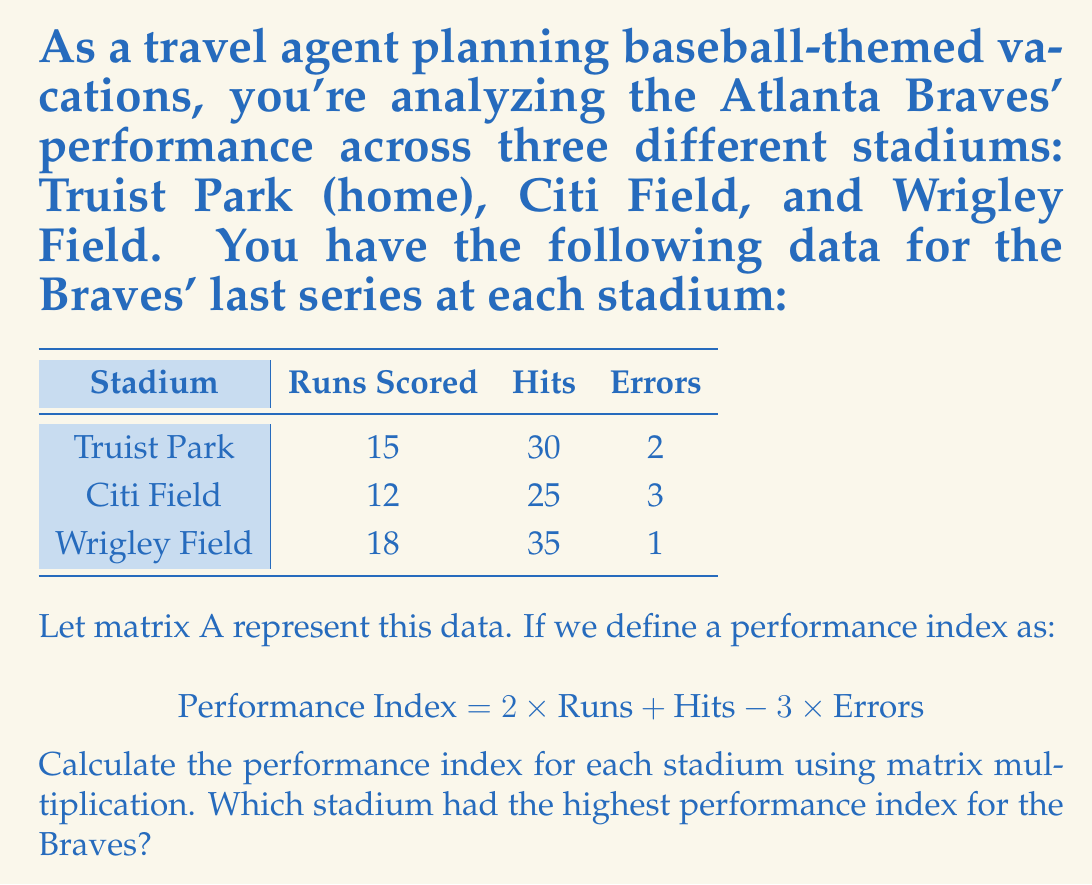Can you answer this question? Let's approach this step-by-step:

1) First, we need to set up our matrices. Matrix A will represent our data:

   $$A = \begin{bmatrix}
   15 & 30 & 2 \\
   12 & 25 & 3 \\
   18 & 35 & 1
   \end{bmatrix}$$

2) We need a column vector B to represent our performance index formula:

   $$B = \begin{bmatrix}
   2 \\
   1 \\
   -3
   \end{bmatrix}$$

3) To calculate the performance index for each stadium, we need to multiply A and B:

   $$\text{Performance Index} = A \times B$$

4) Let's perform the matrix multiplication:

   $$\begin{bmatrix}
   15 & 30 & 2 \\
   12 & 25 & 3 \\
   18 & 35 & 1
   \end{bmatrix} \times
   \begin{bmatrix}
   2 \\
   1 \\
   -3
   \end{bmatrix} =
   \begin{bmatrix}
   (15 \times 2) + (30 \times 1) + (2 \times -3) \\
   (12 \times 2) + (25 \times 1) + (3 \times -3) \\
   (18 \times 2) + (35 \times 1) + (1 \times -3)
   \end{bmatrix}$$

5) Calculating each row:

   $$= \begin{bmatrix}
   30 + 30 - 6 \\
   24 + 25 - 9 \\
   36 + 35 - 3
   \end{bmatrix} =
   \begin{bmatrix}
   54 \\
   40 \\
   68
   \end{bmatrix}$$

6) Therefore, the performance indices are:
   - Truist Park: 54
   - Citi Field: 40
   - Wrigley Field: 68

7) The highest performance index is 68, corresponding to Wrigley Field.
Answer: Wrigley Field (68) 